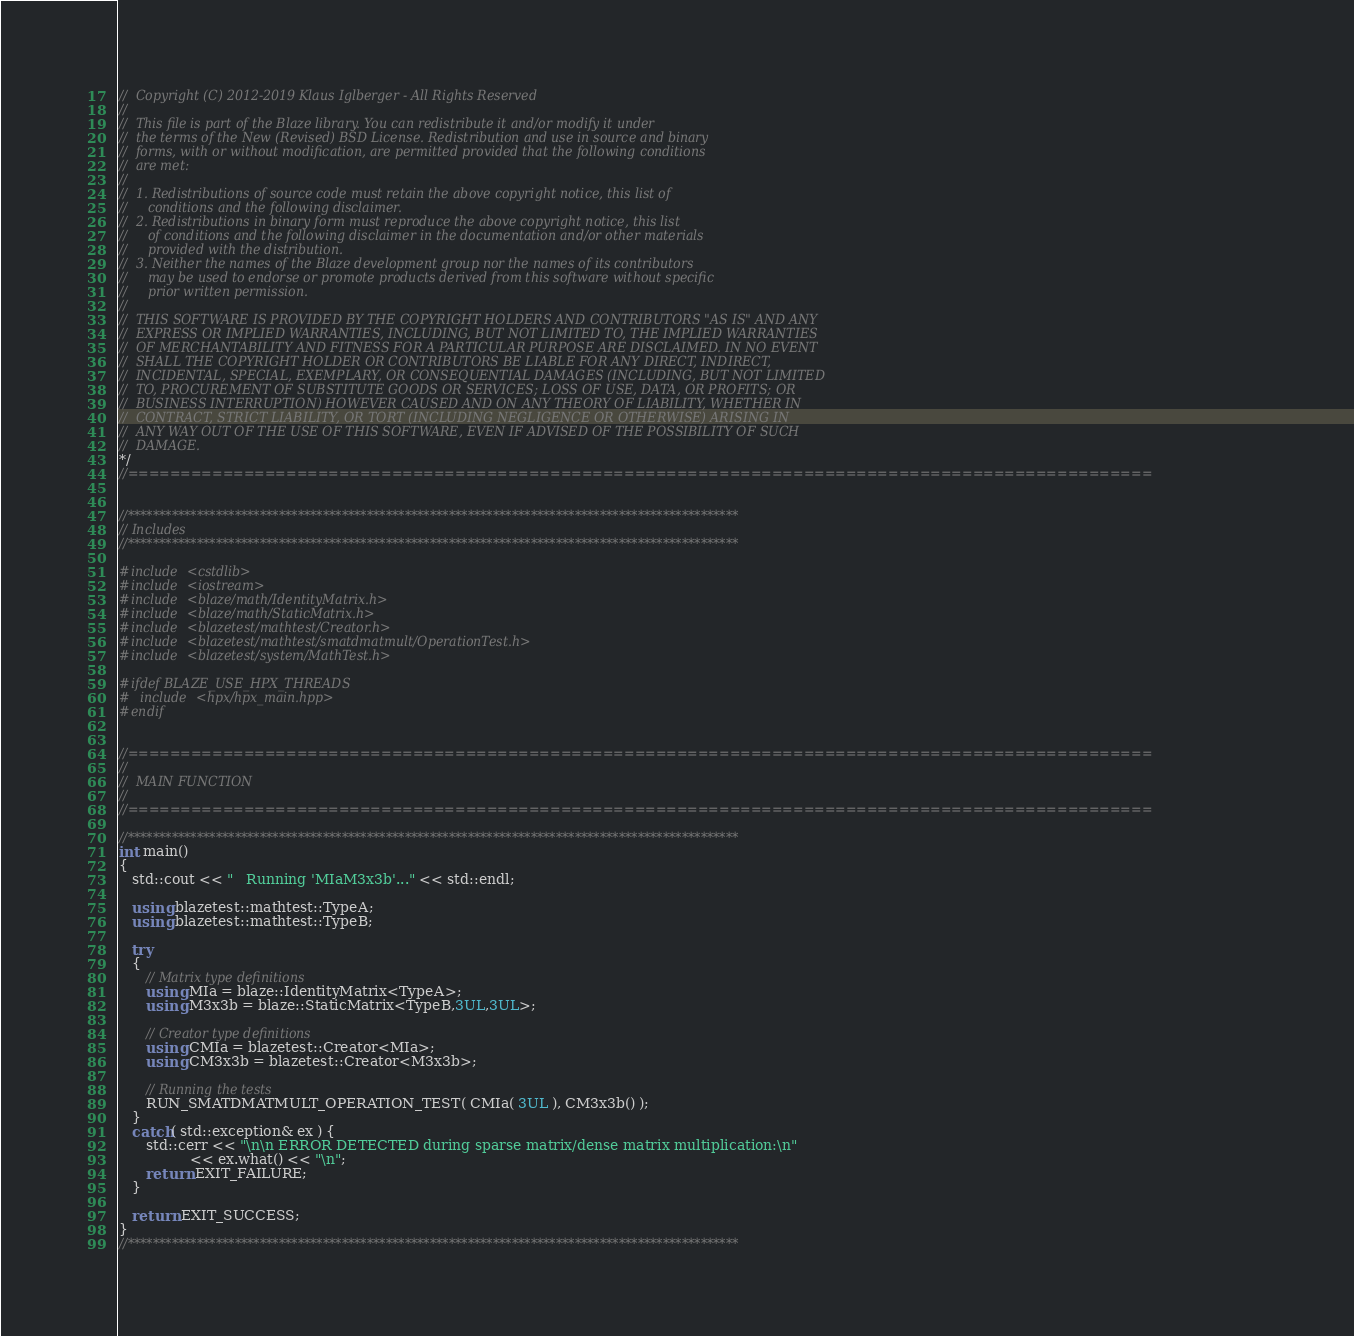<code> <loc_0><loc_0><loc_500><loc_500><_C++_>//  Copyright (C) 2012-2019 Klaus Iglberger - All Rights Reserved
//
//  This file is part of the Blaze library. You can redistribute it and/or modify it under
//  the terms of the New (Revised) BSD License. Redistribution and use in source and binary
//  forms, with or without modification, are permitted provided that the following conditions
//  are met:
//
//  1. Redistributions of source code must retain the above copyright notice, this list of
//     conditions and the following disclaimer.
//  2. Redistributions in binary form must reproduce the above copyright notice, this list
//     of conditions and the following disclaimer in the documentation and/or other materials
//     provided with the distribution.
//  3. Neither the names of the Blaze development group nor the names of its contributors
//     may be used to endorse or promote products derived from this software without specific
//     prior written permission.
//
//  THIS SOFTWARE IS PROVIDED BY THE COPYRIGHT HOLDERS AND CONTRIBUTORS "AS IS" AND ANY
//  EXPRESS OR IMPLIED WARRANTIES, INCLUDING, BUT NOT LIMITED TO, THE IMPLIED WARRANTIES
//  OF MERCHANTABILITY AND FITNESS FOR A PARTICULAR PURPOSE ARE DISCLAIMED. IN NO EVENT
//  SHALL THE COPYRIGHT HOLDER OR CONTRIBUTORS BE LIABLE FOR ANY DIRECT, INDIRECT,
//  INCIDENTAL, SPECIAL, EXEMPLARY, OR CONSEQUENTIAL DAMAGES (INCLUDING, BUT NOT LIMITED
//  TO, PROCUREMENT OF SUBSTITUTE GOODS OR SERVICES; LOSS OF USE, DATA, OR PROFITS; OR
//  BUSINESS INTERRUPTION) HOWEVER CAUSED AND ON ANY THEORY OF LIABILITY, WHETHER IN
//  CONTRACT, STRICT LIABILITY, OR TORT (INCLUDING NEGLIGENCE OR OTHERWISE) ARISING IN
//  ANY WAY OUT OF THE USE OF THIS SOFTWARE, EVEN IF ADVISED OF THE POSSIBILITY OF SUCH
//  DAMAGE.
*/
//=================================================================================================


//*************************************************************************************************
// Includes
//*************************************************************************************************

#include <cstdlib>
#include <iostream>
#include <blaze/math/IdentityMatrix.h>
#include <blaze/math/StaticMatrix.h>
#include <blazetest/mathtest/Creator.h>
#include <blazetest/mathtest/smatdmatmult/OperationTest.h>
#include <blazetest/system/MathTest.h>

#ifdef BLAZE_USE_HPX_THREADS
#  include <hpx/hpx_main.hpp>
#endif


//=================================================================================================
//
//  MAIN FUNCTION
//
//=================================================================================================

//*************************************************************************************************
int main()
{
   std::cout << "   Running 'MIaM3x3b'..." << std::endl;

   using blazetest::mathtest::TypeA;
   using blazetest::mathtest::TypeB;

   try
   {
      // Matrix type definitions
      using MIa = blaze::IdentityMatrix<TypeA>;
      using M3x3b = blaze::StaticMatrix<TypeB,3UL,3UL>;

      // Creator type definitions
      using CMIa = blazetest::Creator<MIa>;
      using CM3x3b = blazetest::Creator<M3x3b>;

      // Running the tests
      RUN_SMATDMATMULT_OPERATION_TEST( CMIa( 3UL ), CM3x3b() );
   }
   catch( std::exception& ex ) {
      std::cerr << "\n\n ERROR DETECTED during sparse matrix/dense matrix multiplication:\n"
                << ex.what() << "\n";
      return EXIT_FAILURE;
   }

   return EXIT_SUCCESS;
}
//*************************************************************************************************
</code> 